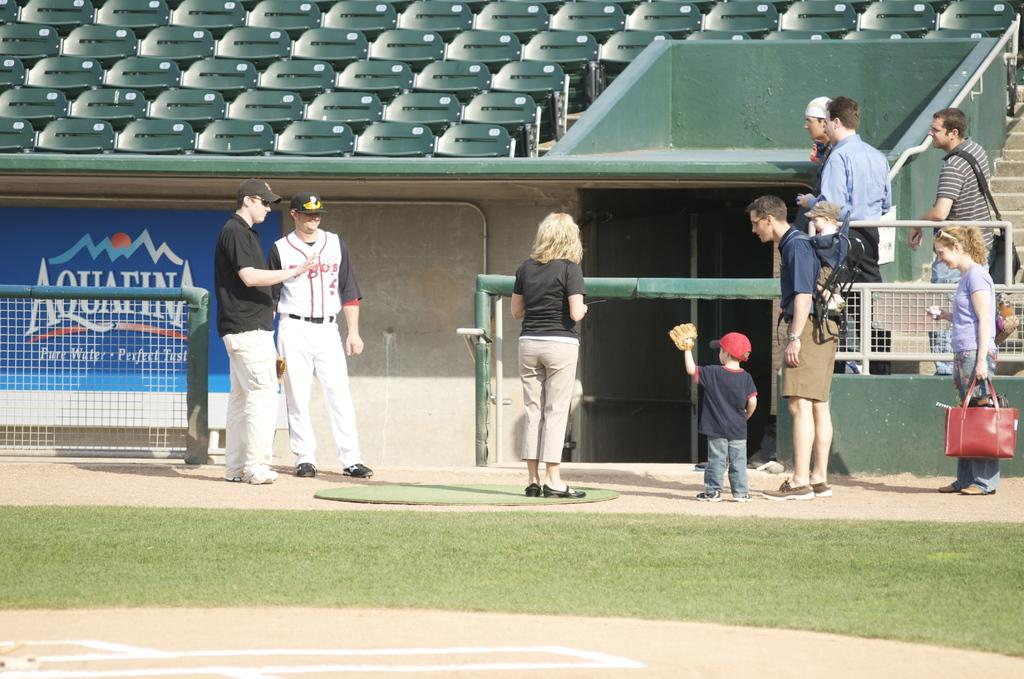<image>
Describe the image concisely. People stand around a baseball field with an Aquafina advertisement. 